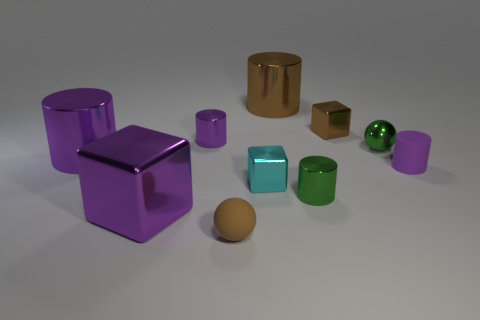Are there any patterns or consistencies in the colors of the objects? Yes, there is a noticeable pattern in the colors of the objects. The objects are primarily metallic and are in shades of purple, green, gold, and cyan. The purple and green objects appear more frequently than the gold and cyan ones. Also, similar shapes tend to have consistent colors, such as the two purple cubes and the green cylinders. 